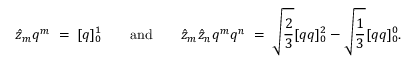<formula> <loc_0><loc_0><loc_500><loc_500>\hat { z } _ { m } q ^ { m } \, = \, [ q ] _ { 0 } ^ { 1 } \quad a n d \quad \hat { z } _ { m } \hat { z } _ { n } q ^ { m } q ^ { n } \, = \, \sqrt { \frac { 2 } { 3 } } [ q q ] _ { 0 } ^ { 2 } - \sqrt { \frac { 1 } { 3 } } [ q q ] _ { 0 } ^ { 0 } .</formula> 